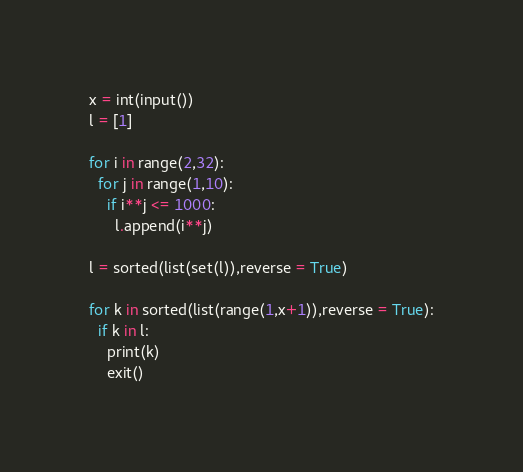<code> <loc_0><loc_0><loc_500><loc_500><_Python_>x = int(input())
l = [1]

for i in range(2,32):
  for j in range(1,10):
    if i**j <= 1000:
      l.append(i**j)
      
l = sorted(list(set(l)),reverse = True)

for k in sorted(list(range(1,x+1)),reverse = True):
  if k in l:
    print(k)
    exit()</code> 